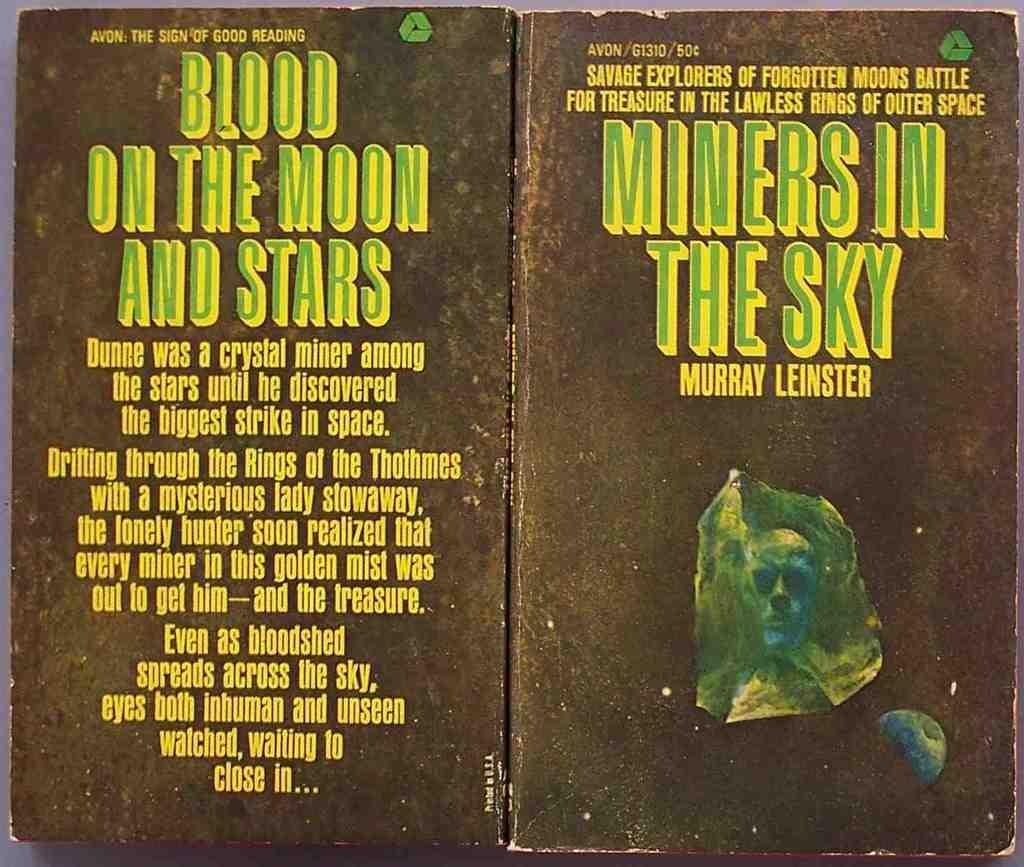What is on the moon and stars?
Make the answer very short. Blood. 